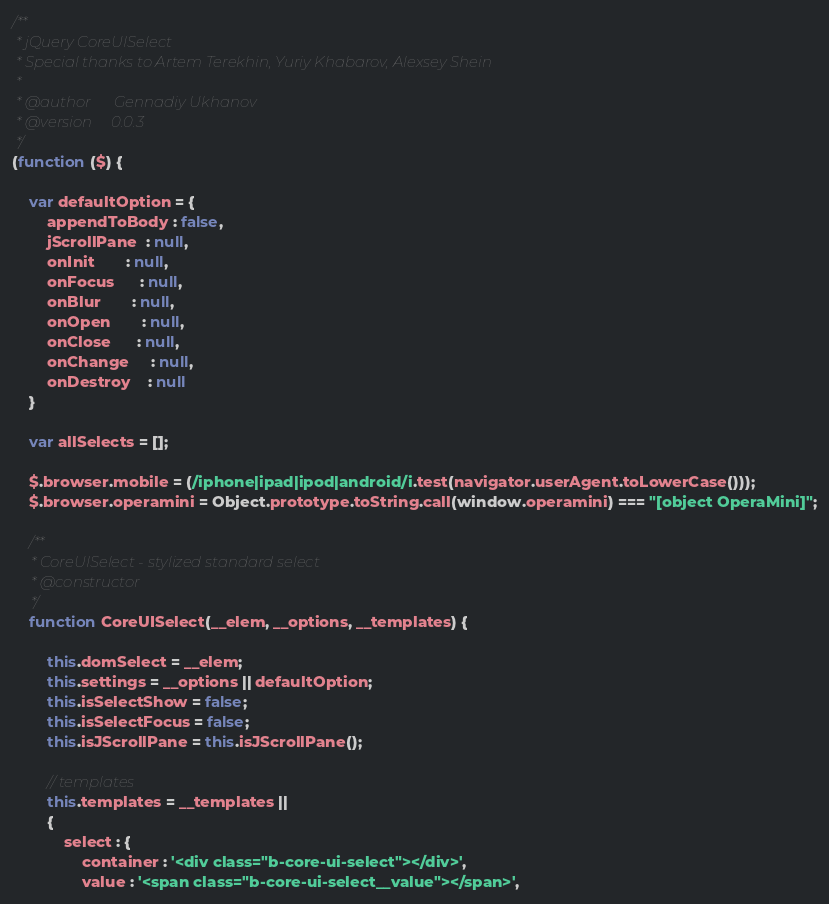Convert code to text. <code><loc_0><loc_0><loc_500><loc_500><_JavaScript_>/**
 * jQuery CoreUISelect
 * Special thanks to Artem Terekhin, Yuriy Khabarov, Alexsey Shein
 *
 * @author      Gennadiy Ukhanov
 * @version     0.0.3
 */
(function ($) {

    var defaultOption = {
        appendToBody : false,
        jScrollPane  : null,
        onInit       : null,
        onFocus      : null,
        onBlur       : null,
        onOpen       : null,
        onClose      : null,
        onChange     : null,
        onDestroy    : null
    }

    var allSelects = [];

    $.browser.mobile = (/iphone|ipad|ipod|android/i.test(navigator.userAgent.toLowerCase()));
    $.browser.operamini = Object.prototype.toString.call(window.operamini) === "[object OperaMini]";

    /**
     * CoreUISelect - stylized standard select
     * @constructor
     */
    function CoreUISelect(__elem, __options, __templates) {

        this.domSelect = __elem;
        this.settings = __options || defaultOption;
        this.isSelectShow = false;
        this.isSelectFocus = false;
        this.isJScrollPane = this.isJScrollPane();

        // templates
        this.templates = __templates ||
        {
            select : {
                container : '<div class="b-core-ui-select"></div>',
                value : '<span class="b-core-ui-select__value"></span>',</code> 